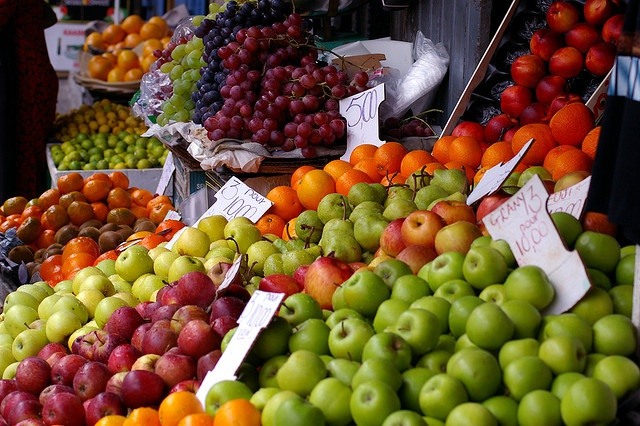Describe the objects in this image and their specific colors. I can see apple in maroon, black, olive, and lavender tones, orange in maroon, brown, and red tones, apple in maroon, brown, and black tones, orange in maroon, brown, and red tones, and orange in maroon, black, and brown tones in this image. 